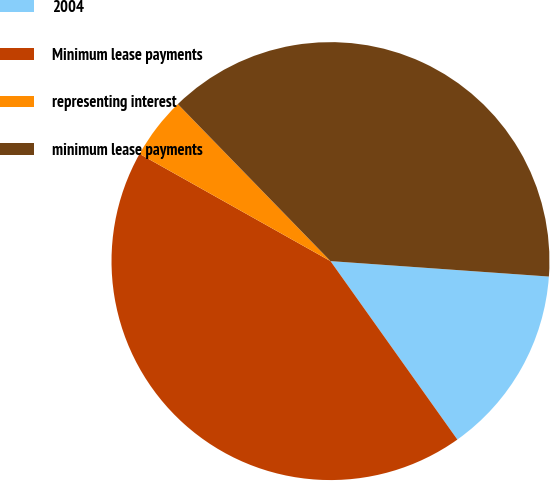Convert chart. <chart><loc_0><loc_0><loc_500><loc_500><pie_chart><fcel>2004<fcel>Minimum lease payments<fcel>representing interest<fcel>minimum lease payments<nl><fcel>14.04%<fcel>42.98%<fcel>4.58%<fcel>38.4%<nl></chart> 